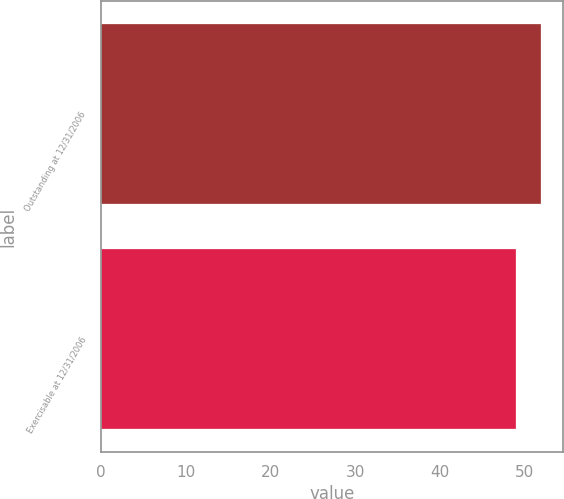Convert chart. <chart><loc_0><loc_0><loc_500><loc_500><bar_chart><fcel>Outstanding at 12/31/2006<fcel>Exercisable at 12/31/2006<nl><fcel>52<fcel>49<nl></chart> 